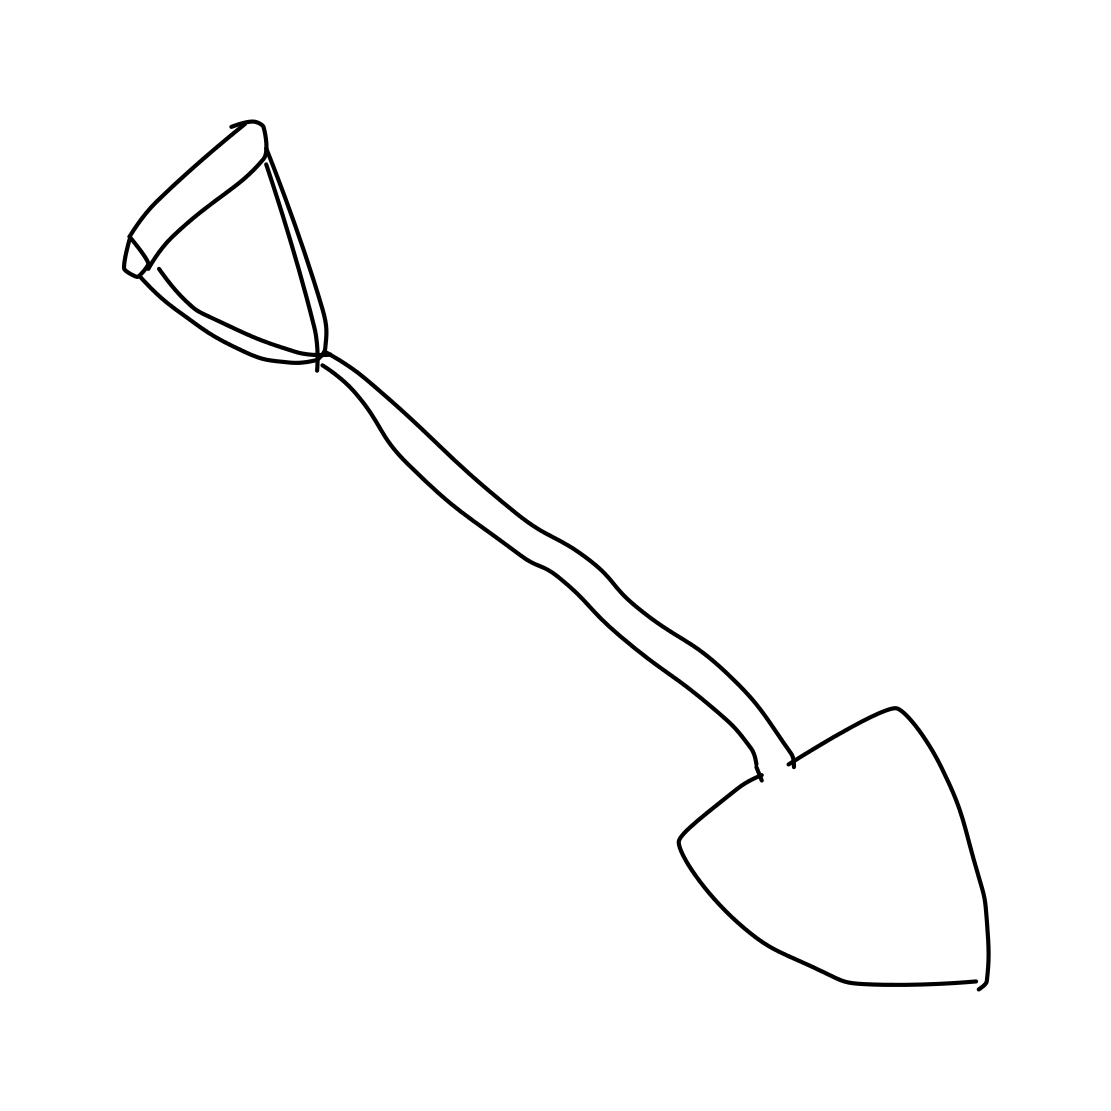Is there a sketchy shovel in the picture? Indeed, the image displays a drawing of a shovel, characterised by simple lines giving it a sketch-like appearance. It presents a long handle connected to a pointed tip, which is typical of digging tools designed to penetrate the ground for various gardening or construction tasks. 